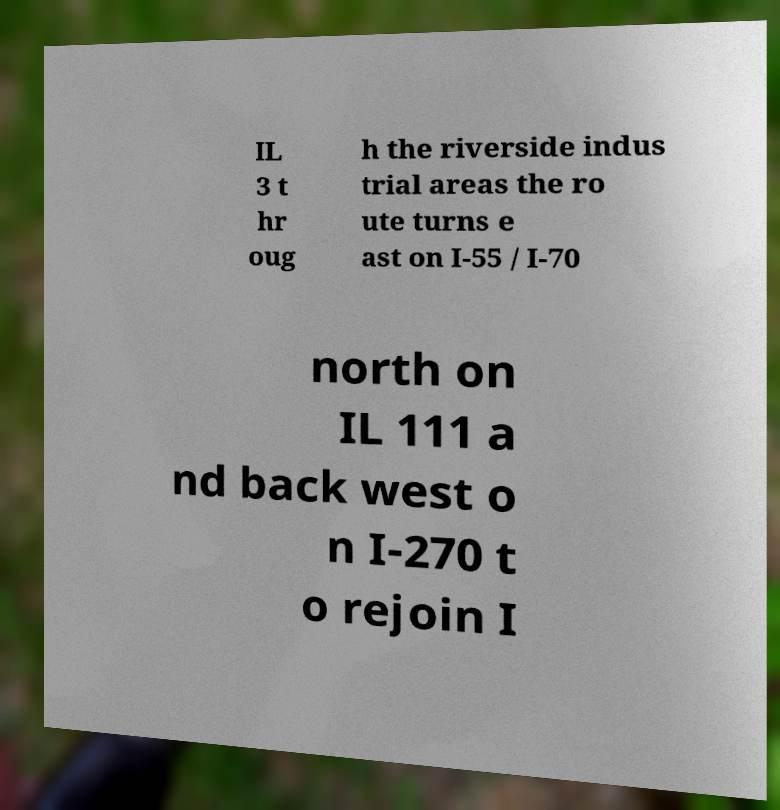Please identify and transcribe the text found in this image. IL 3 t hr oug h the riverside indus trial areas the ro ute turns e ast on I-55 / I-70 north on IL 111 a nd back west o n I-270 t o rejoin I 